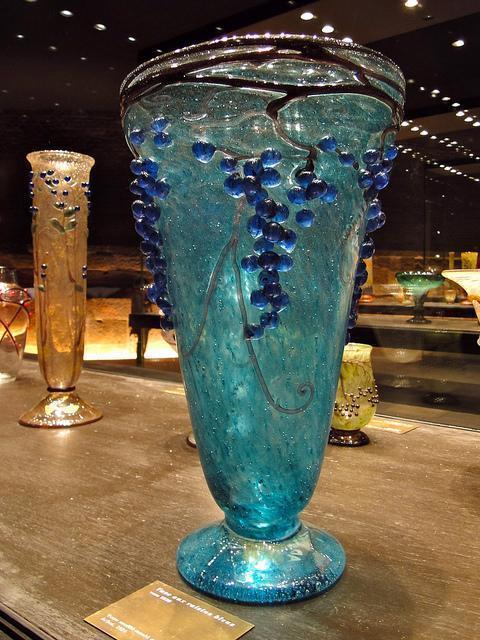What venue is this likely to be?
From the following four choices, select the correct answer to address the question.
Options: Art gallery, restaurant, hotel, department store. Art gallery. 